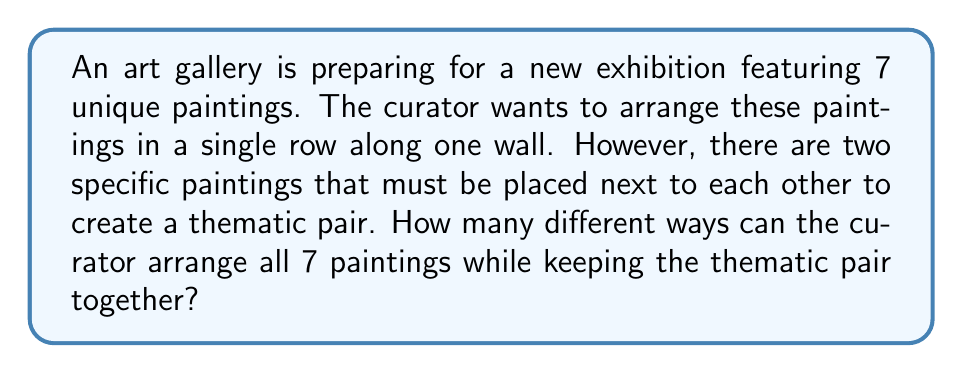Could you help me with this problem? Let's approach this step-by-step:

1) First, we can consider the thematic pair as a single unit. This effectively reduces our problem to arranging 6 units (5 individual paintings and 1 pair).

2) The number of ways to arrange 6 distinct units is simply 6!, which is:

   $$6! = 6 \times 5 \times 4 \times 3 \times 2 \times 1 = 720$$

3) However, we're not done yet. For each of these 720 arrangements, the thematic pair itself can be arranged in 2 ways (either painting can be on the left or right of the other).

4) Therefore, we need to multiply our result by 2:

   $$720 \times 2 = 1440$$

This gives us the total number of possible arrangements.

To visualize this, we can think of it as:

[asy]
size(200,50);
for(int i=0; i<6; ++i) {
  draw((i*30,0)--(i*30,30), black+1);
}
draw((0,0)--(150,0)--(150,30)--(0,30)--cycle, black+1);
label("1", (15,15));
label("2", (45,15));
label("3", (75,15));
label("4", (105,15));
label("5", (135,15));
label("Pair", (75,45));
[/asy]

Where "Pair" represents our thematic pair, and the numbers represent the other paintings. This diagram shows one of the 720 possible arrangements of the 6 units, and for each of these, the pair itself has 2 possible arrangements.
Answer: 1440 